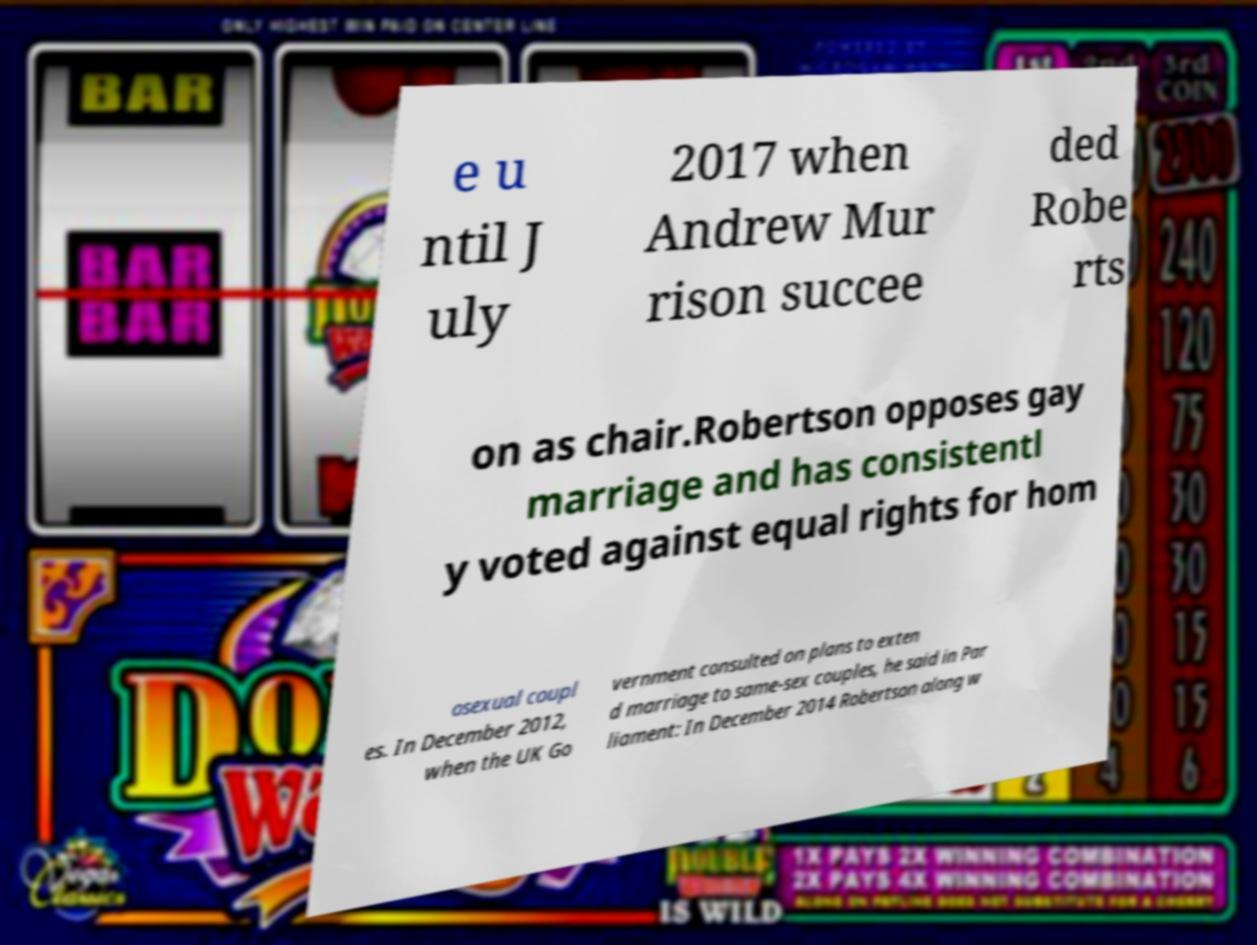What messages or text are displayed in this image? I need them in a readable, typed format. e u ntil J uly 2017 when Andrew Mur rison succee ded Robe rts on as chair.Robertson opposes gay marriage and has consistentl y voted against equal rights for hom osexual coupl es. In December 2012, when the UK Go vernment consulted on plans to exten d marriage to same-sex couples, he said in Par liament: In December 2014 Robertson along w 